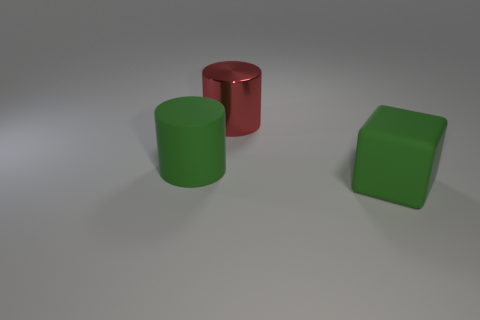Imagine these objects were part of a larger scene, what could that look like? If these objects were part of a larger scene, they could be sitting on a designer's worktable as prototypes for products, components of an abstract art installation, or even as educational tools in a classroom setting. The simplicity of forms and the primary colors suggest a setting focused on design, art, or education. 